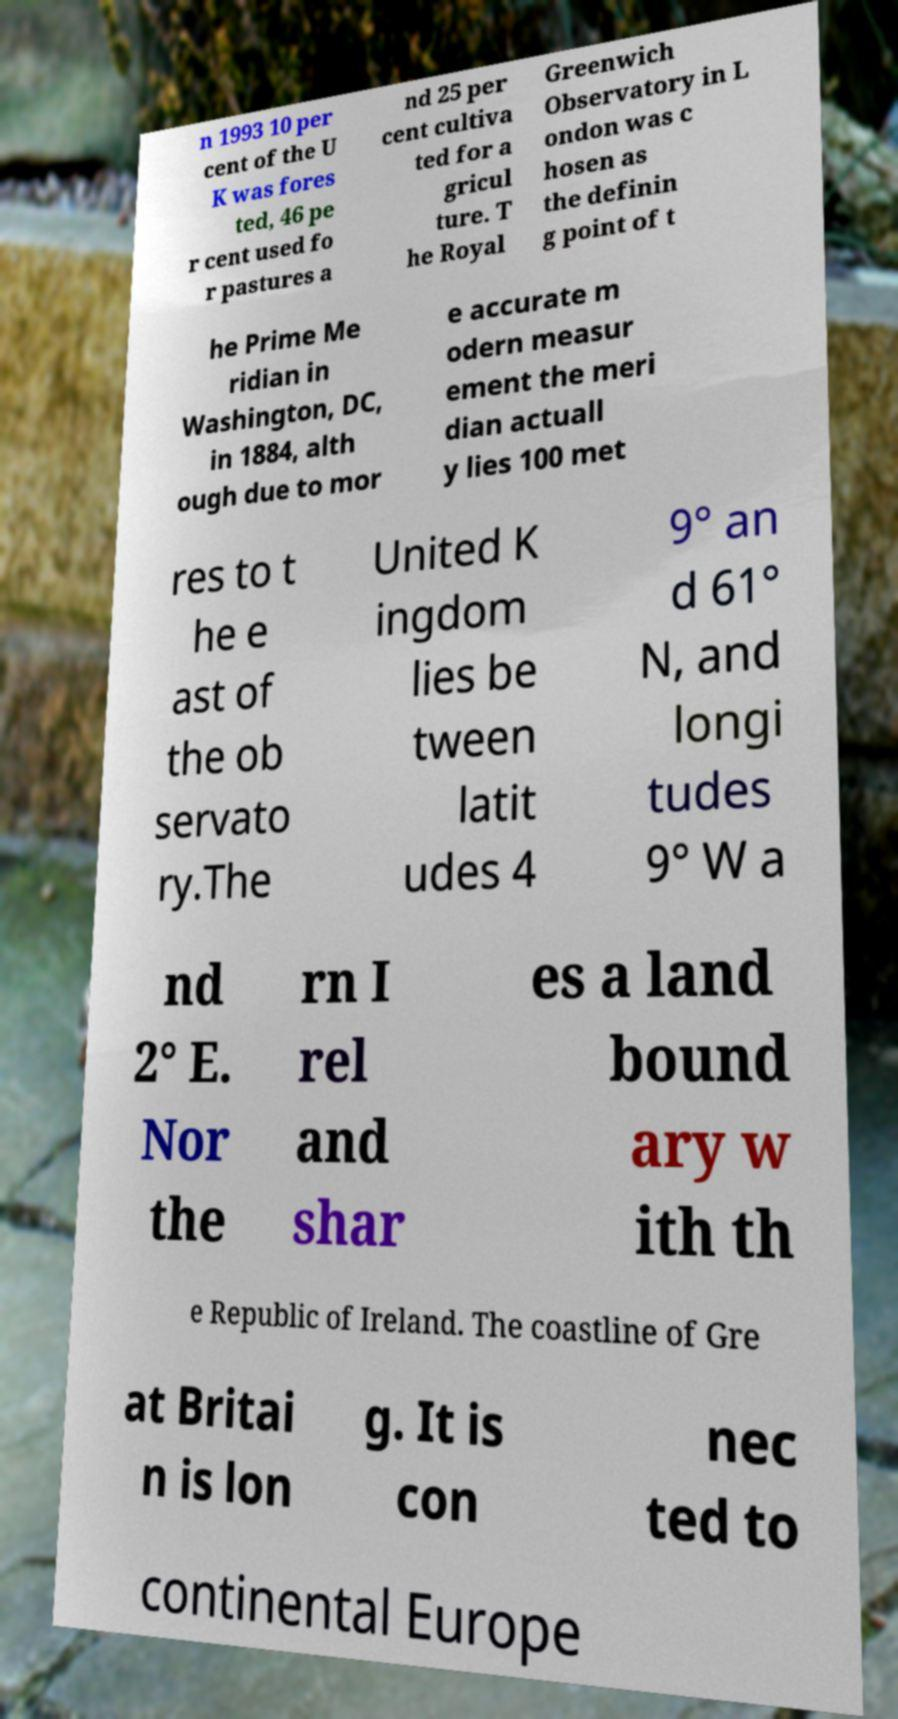What messages or text are displayed in this image? I need them in a readable, typed format. n 1993 10 per cent of the U K was fores ted, 46 pe r cent used fo r pastures a nd 25 per cent cultiva ted for a gricul ture. T he Royal Greenwich Observatory in L ondon was c hosen as the definin g point of t he Prime Me ridian in Washington, DC, in 1884, alth ough due to mor e accurate m odern measur ement the meri dian actuall y lies 100 met res to t he e ast of the ob servato ry.The United K ingdom lies be tween latit udes 4 9° an d 61° N, and longi tudes 9° W a nd 2° E. Nor the rn I rel and shar es a land bound ary w ith th e Republic of Ireland. The coastline of Gre at Britai n is lon g. It is con nec ted to continental Europe 